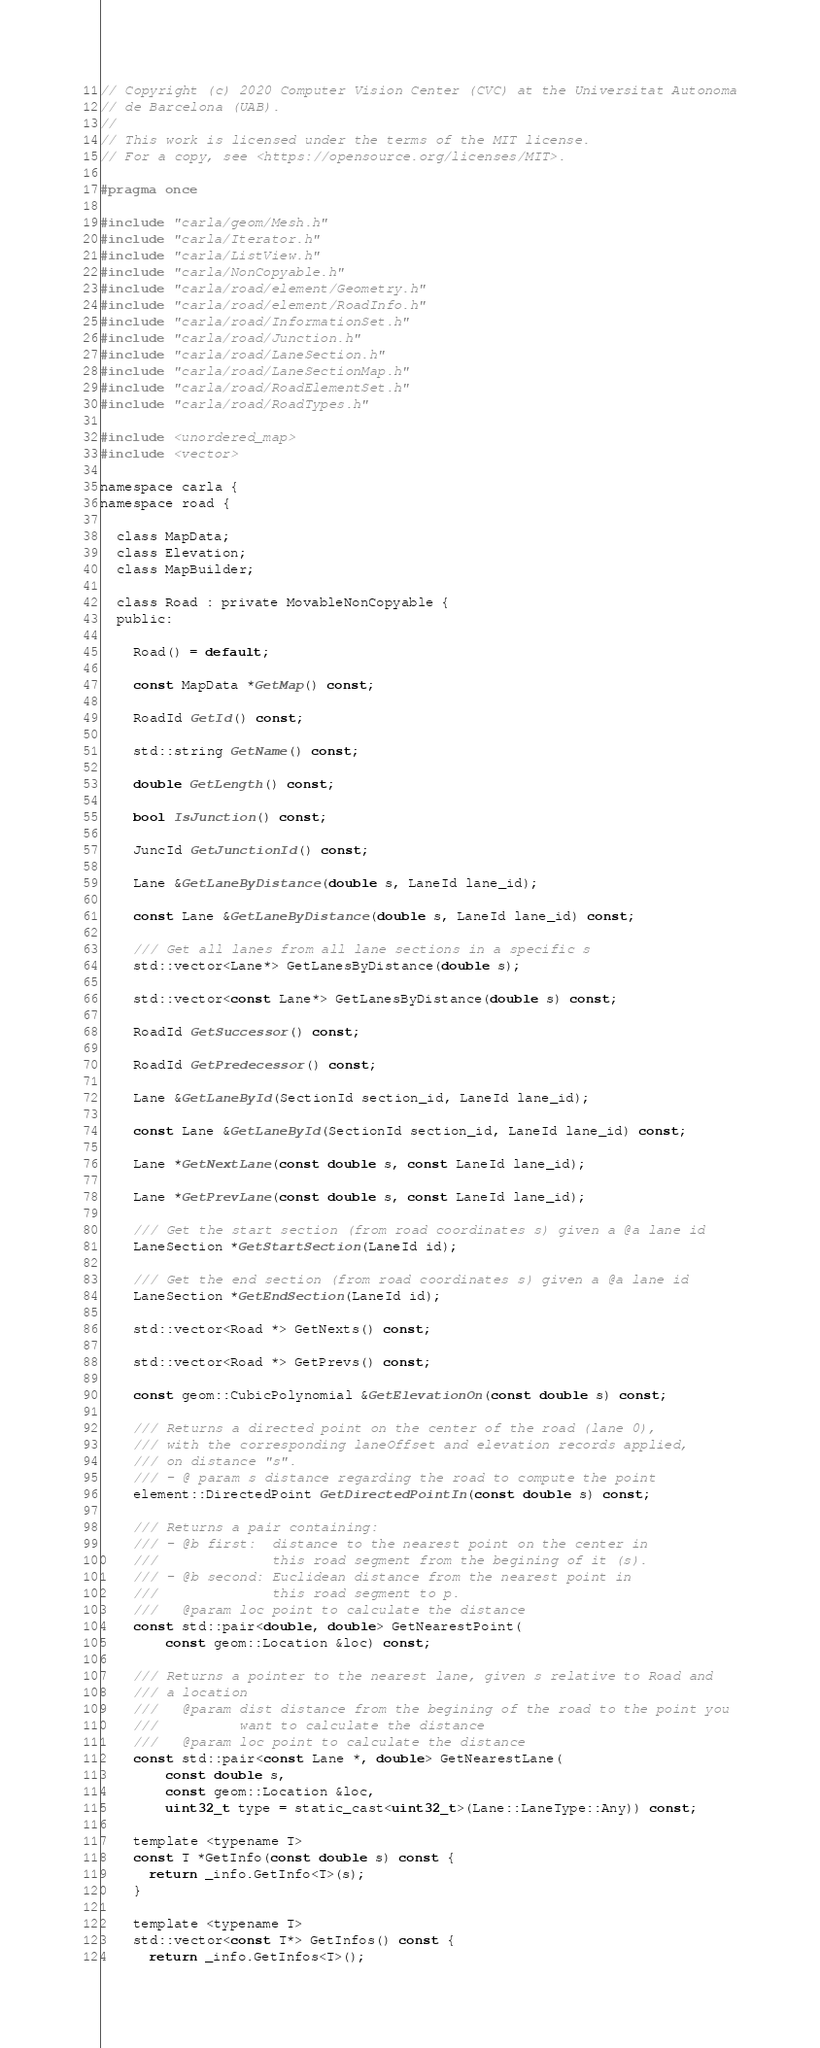Convert code to text. <code><loc_0><loc_0><loc_500><loc_500><_C_>// Copyright (c) 2020 Computer Vision Center (CVC) at the Universitat Autonoma
// de Barcelona (UAB).
//
// This work is licensed under the terms of the MIT license.
// For a copy, see <https://opensource.org/licenses/MIT>.

#pragma once

#include "carla/geom/Mesh.h"
#include "carla/Iterator.h"
#include "carla/ListView.h"
#include "carla/NonCopyable.h"
#include "carla/road/element/Geometry.h"
#include "carla/road/element/RoadInfo.h"
#include "carla/road/InformationSet.h"
#include "carla/road/Junction.h"
#include "carla/road/LaneSection.h"
#include "carla/road/LaneSectionMap.h"
#include "carla/road/RoadElementSet.h"
#include "carla/road/RoadTypes.h"

#include <unordered_map>
#include <vector>

namespace carla {
namespace road {

  class MapData;
  class Elevation;
  class MapBuilder;

  class Road : private MovableNonCopyable {
  public:

    Road() = default;

    const MapData *GetMap() const;

    RoadId GetId() const;

    std::string GetName() const;

    double GetLength() const;

    bool IsJunction() const;

    JuncId GetJunctionId() const;

    Lane &GetLaneByDistance(double s, LaneId lane_id);

    const Lane &GetLaneByDistance(double s, LaneId lane_id) const;

    /// Get all lanes from all lane sections in a specific s
    std::vector<Lane*> GetLanesByDistance(double s);

    std::vector<const Lane*> GetLanesByDistance(double s) const;

    RoadId GetSuccessor() const;

    RoadId GetPredecessor() const;

    Lane &GetLaneById(SectionId section_id, LaneId lane_id);

    const Lane &GetLaneById(SectionId section_id, LaneId lane_id) const;

    Lane *GetNextLane(const double s, const LaneId lane_id);

    Lane *GetPrevLane(const double s, const LaneId lane_id);

    /// Get the start section (from road coordinates s) given a @a lane id
    LaneSection *GetStartSection(LaneId id);

    /// Get the end section (from road coordinates s) given a @a lane id
    LaneSection *GetEndSection(LaneId id);

    std::vector<Road *> GetNexts() const;

    std::vector<Road *> GetPrevs() const;

    const geom::CubicPolynomial &GetElevationOn(const double s) const;

    /// Returns a directed point on the center of the road (lane 0),
    /// with the corresponding laneOffset and elevation records applied,
    /// on distance "s".
    /// - @ param s distance regarding the road to compute the point
    element::DirectedPoint GetDirectedPointIn(const double s) const;

    /// Returns a pair containing:
    /// - @b first:  distance to the nearest point on the center in
    ///              this road segment from the begining of it (s).
    /// - @b second: Euclidean distance from the nearest point in
    ///              this road segment to p.
    ///   @param loc point to calculate the distance
    const std::pair<double, double> GetNearestPoint(
        const geom::Location &loc) const;

    /// Returns a pointer to the nearest lane, given s relative to Road and
    /// a location
    ///   @param dist distance from the begining of the road to the point you
    ///          want to calculate the distance
    ///   @param loc point to calculate the distance
    const std::pair<const Lane *, double> GetNearestLane(
        const double s,
        const geom::Location &loc,
        uint32_t type = static_cast<uint32_t>(Lane::LaneType::Any)) const;

    template <typename T>
    const T *GetInfo(const double s) const {
      return _info.GetInfo<T>(s);
    }

    template <typename T>
    std::vector<const T*> GetInfos() const {
      return _info.GetInfos<T>();</code> 